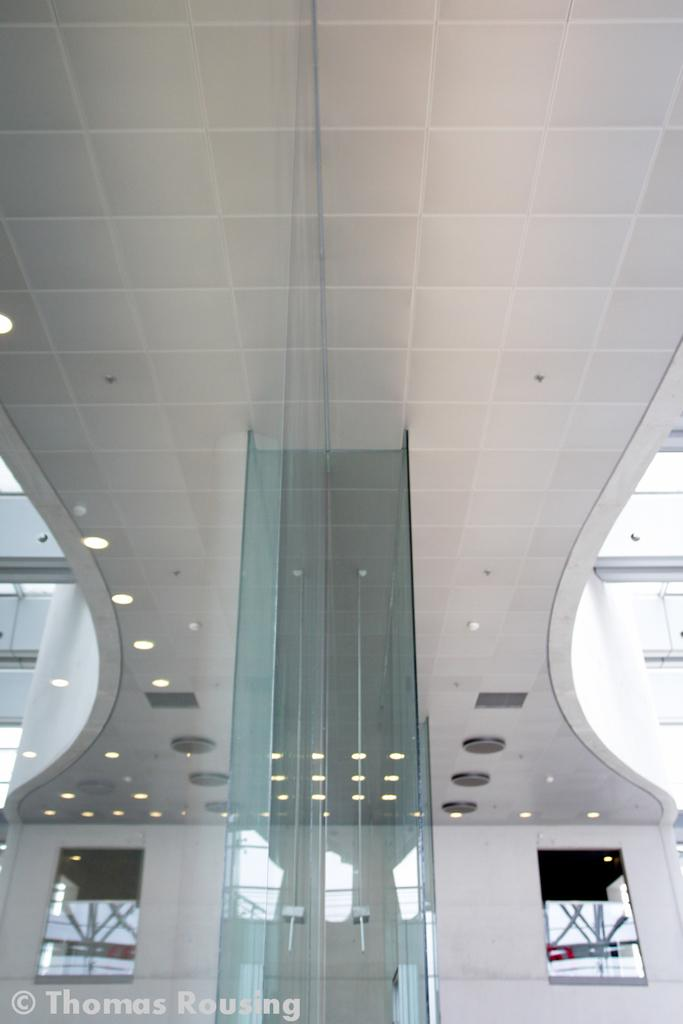What material is present in the image? There is glass in the image. What can be seen illuminating the glass? There are lights in the image. Is there any additional information or branding on the image? Yes, there is a watermark in the image. What type of toothpaste is being used to kick the glass in the image? There is no toothpaste or kicking action present in the image; it only features glass and lights. 